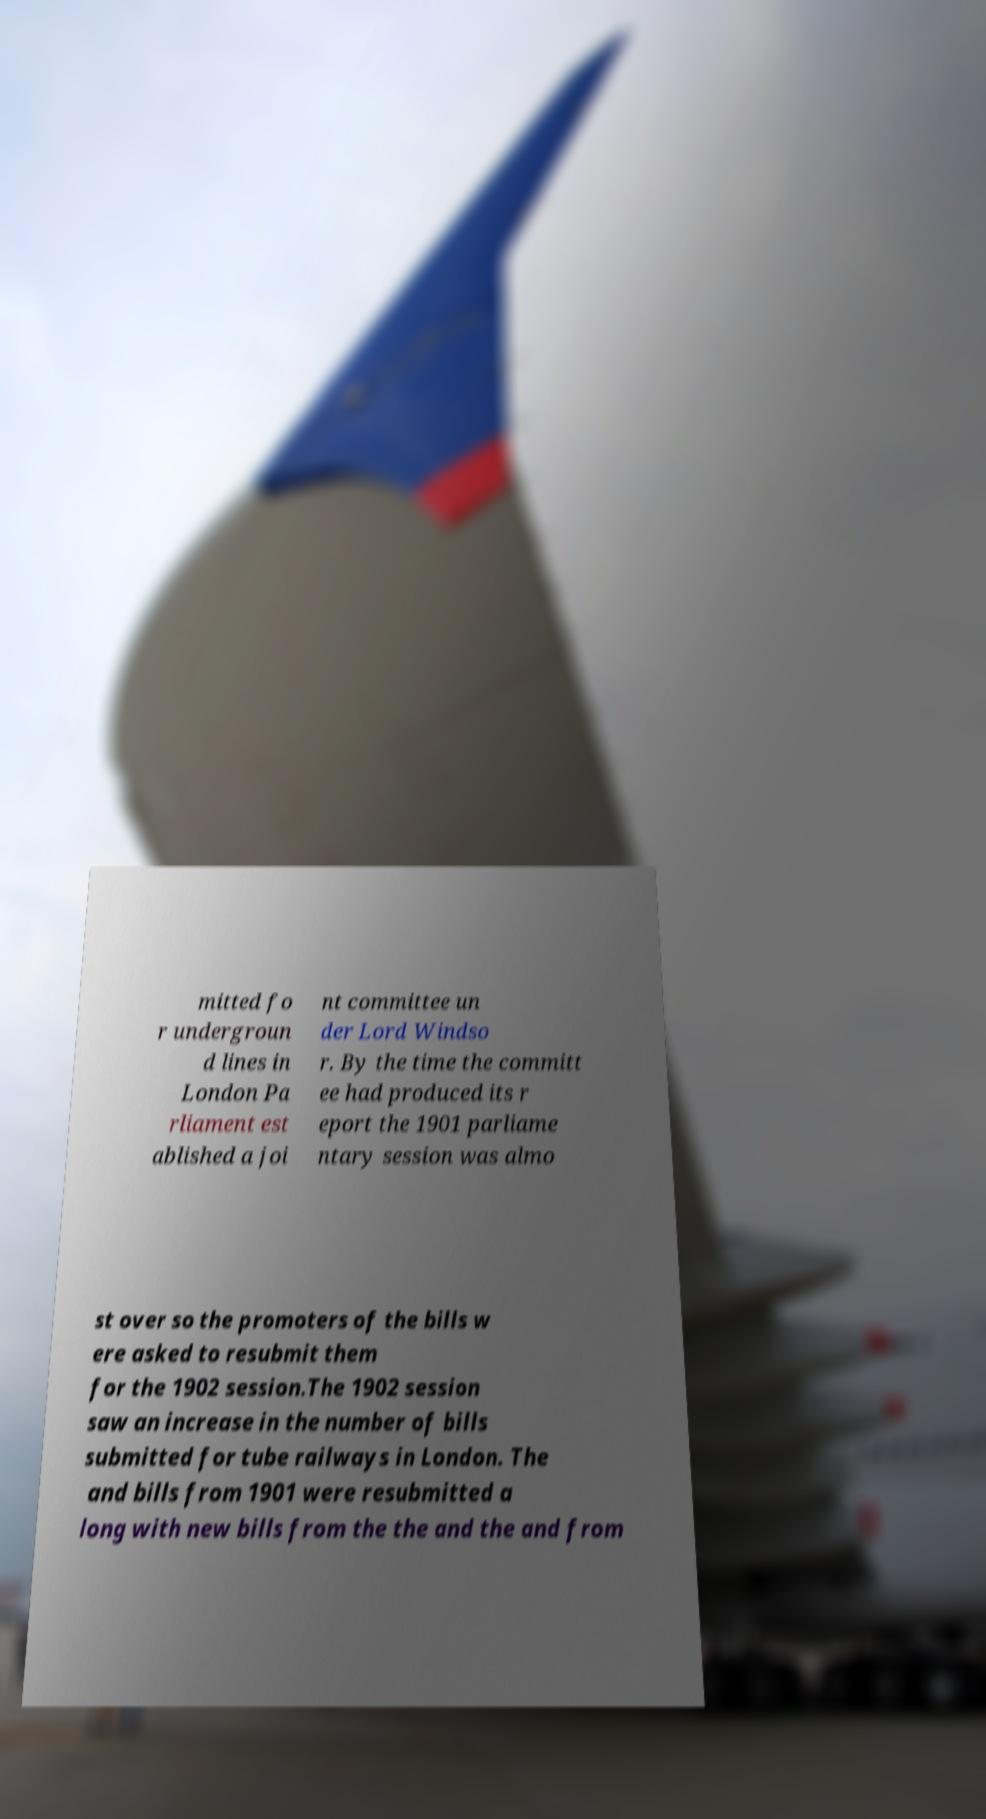Could you extract and type out the text from this image? mitted fo r undergroun d lines in London Pa rliament est ablished a joi nt committee un der Lord Windso r. By the time the committ ee had produced its r eport the 1901 parliame ntary session was almo st over so the promoters of the bills w ere asked to resubmit them for the 1902 session.The 1902 session saw an increase in the number of bills submitted for tube railways in London. The and bills from 1901 were resubmitted a long with new bills from the the and the and from 